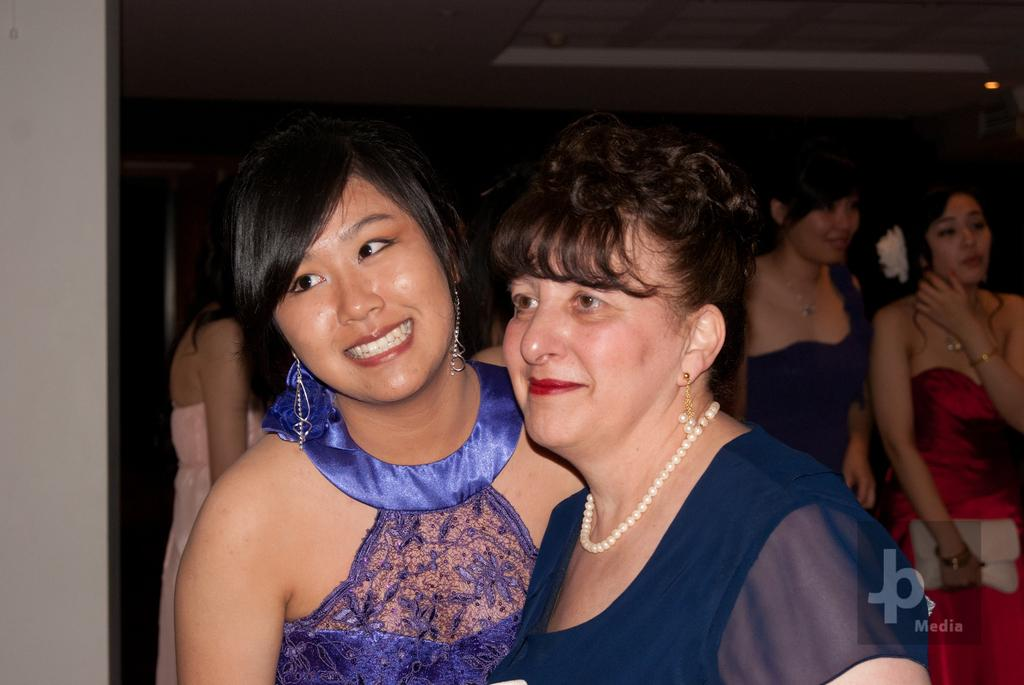What are the women in the image wearing? The women in the image are wearing clothes and earrings. Can you describe any other accessories the women are wearing? Yes, there is a neck chain visible in the image. What type of bag can be seen in the image? There is a handbag in the image. How is the lighting in the image? There is light in the image. What is the facial expression of the women in the image? Two women are smiling in the image. What type of bird can be seen flying in the image? There is no bird visible in the image. What is the temperature of the steam coming from the handbag in the image? There is no steam present in the image. 